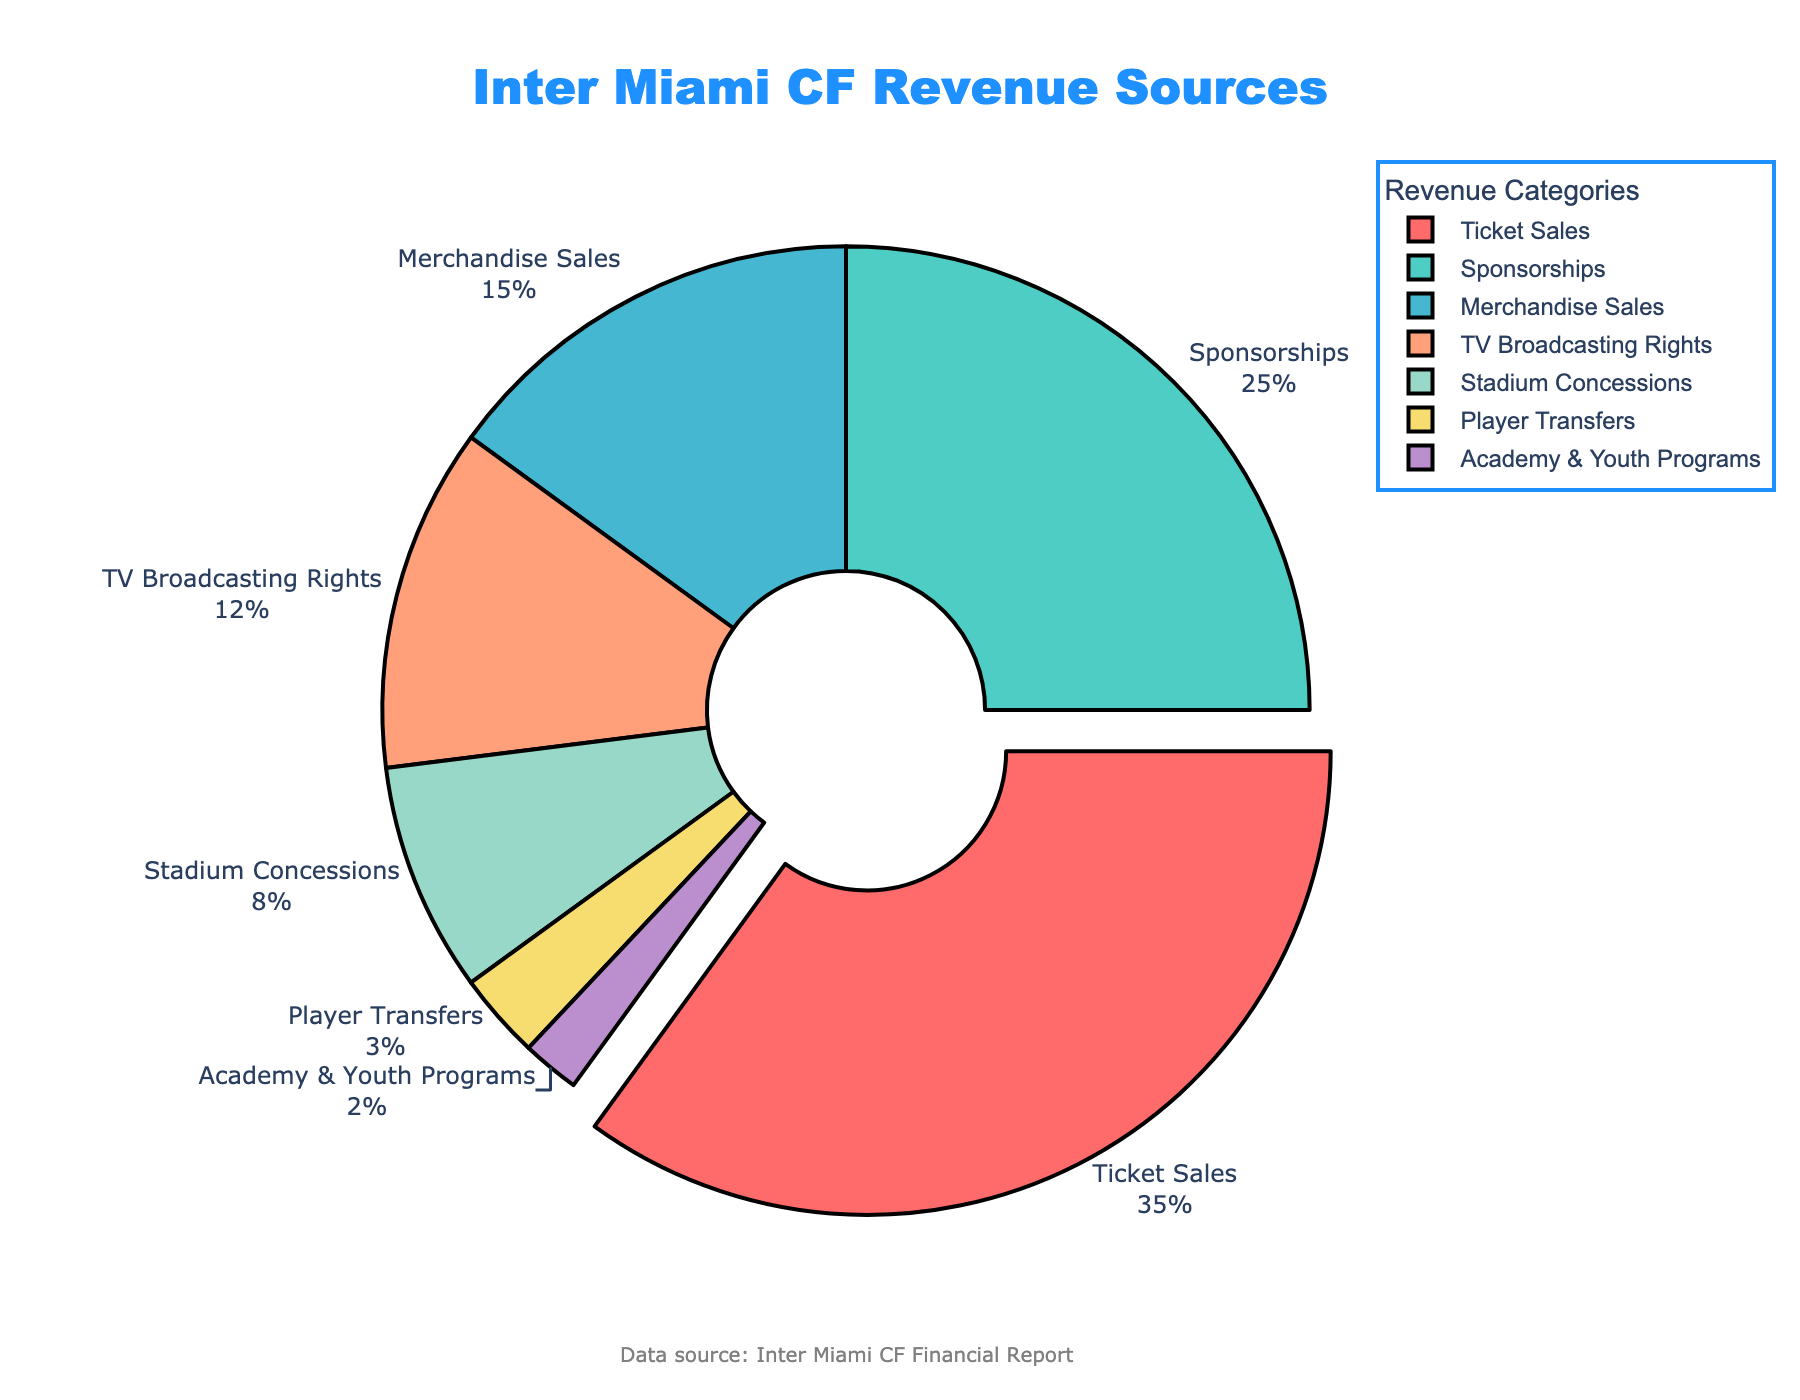Which category provides the highest percentage of revenue for Inter Miami CF? The pie chart indicates the highest percentage of revenue by highlighting the segment most pulled out from the center. Ticket Sales is shown with the largest segment at 35%.
Answer: Ticket Sales What is the combined revenue percentage from TV Broadcasting Rights and Player Transfers? Add the percentages of TV Broadcasting Rights (12%) and Player Transfers (3%). 12 + 3 = 15%
Answer: 15% How much greater is the revenue percentage from Ticket Sales compared to Merchandise Sales? Subtract the percentage of Merchandise Sales (15%) from the percentage of Ticket Sales (35%). 35 - 15 = 20%
Answer: 20% Which category contributes the smallest percentage to Inter Miami CF’s revenue? The smallest segment in the pie chart represents Academy & Youth Programs at 2%.
Answer: Academy & Youth Programs Between Sponsorships and Stadium Concessions, which category generates more revenue and by how much? Compare Sponsorships (25%) and Stadium Concessions (8%). Subtract the smaller percentage from the larger one: 25 - 8 = 17%.
Answer: Sponsorships by 17% What is the total revenue percentage from Ticket Sales, Sponsorships, and Merchandise Sales combined? Add the revenue percentages from Ticket Sales (35%), Sponsorships (25%), and Merchandise Sales (15%). 35 + 25 + 15 = 75%
Answer: 75% Which color represents TV Broadcasting Rights in the pie chart, and what is its revenue percentage? The pie chart uses a specific color scheme to differentiate categories. TV Broadcasting Rights is represented by a color (blue) and has a revenue percentage of 12%.
Answer: Blue, 12% What is the difference in revenue percentages between the highest and lowest revenue sources? Subtract the lowest percentage, Academy & Youth Programs (2%), from the highest percentage, Ticket Sales (35%). 35 - 2 = 33%
Answer: 33% What is the revenue percentage given by categories outside the top three (Ticket Sales, Sponsorships, Merchandise Sales)? Sum the percentages of TV Broadcasting Rights (12%), Stadium Concessions (8%), Player Transfers (3%), and Academy & Youth Programs (2%). 12 + 8 + 3 + 2 = 25%
Answer: 25% How many categories contribute less than 10% to the total revenue? Identify and count the segments below 10%: Stadium Concessions (8%), Player Transfers (3%), and Academy & Youth Programs (2%). There are 3 categories.
Answer: 3 